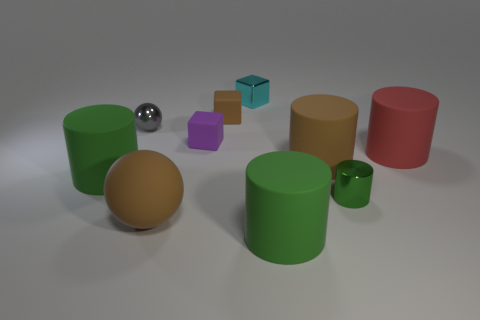Subtract all gray blocks. How many green cylinders are left? 3 Subtract all blue cylinders. Subtract all gray spheres. How many cylinders are left? 5 Subtract all cubes. How many objects are left? 7 Add 6 brown metallic spheres. How many brown metallic spheres exist? 6 Subtract 0 green balls. How many objects are left? 10 Subtract all tiny gray objects. Subtract all purple objects. How many objects are left? 8 Add 7 large brown things. How many large brown things are left? 9 